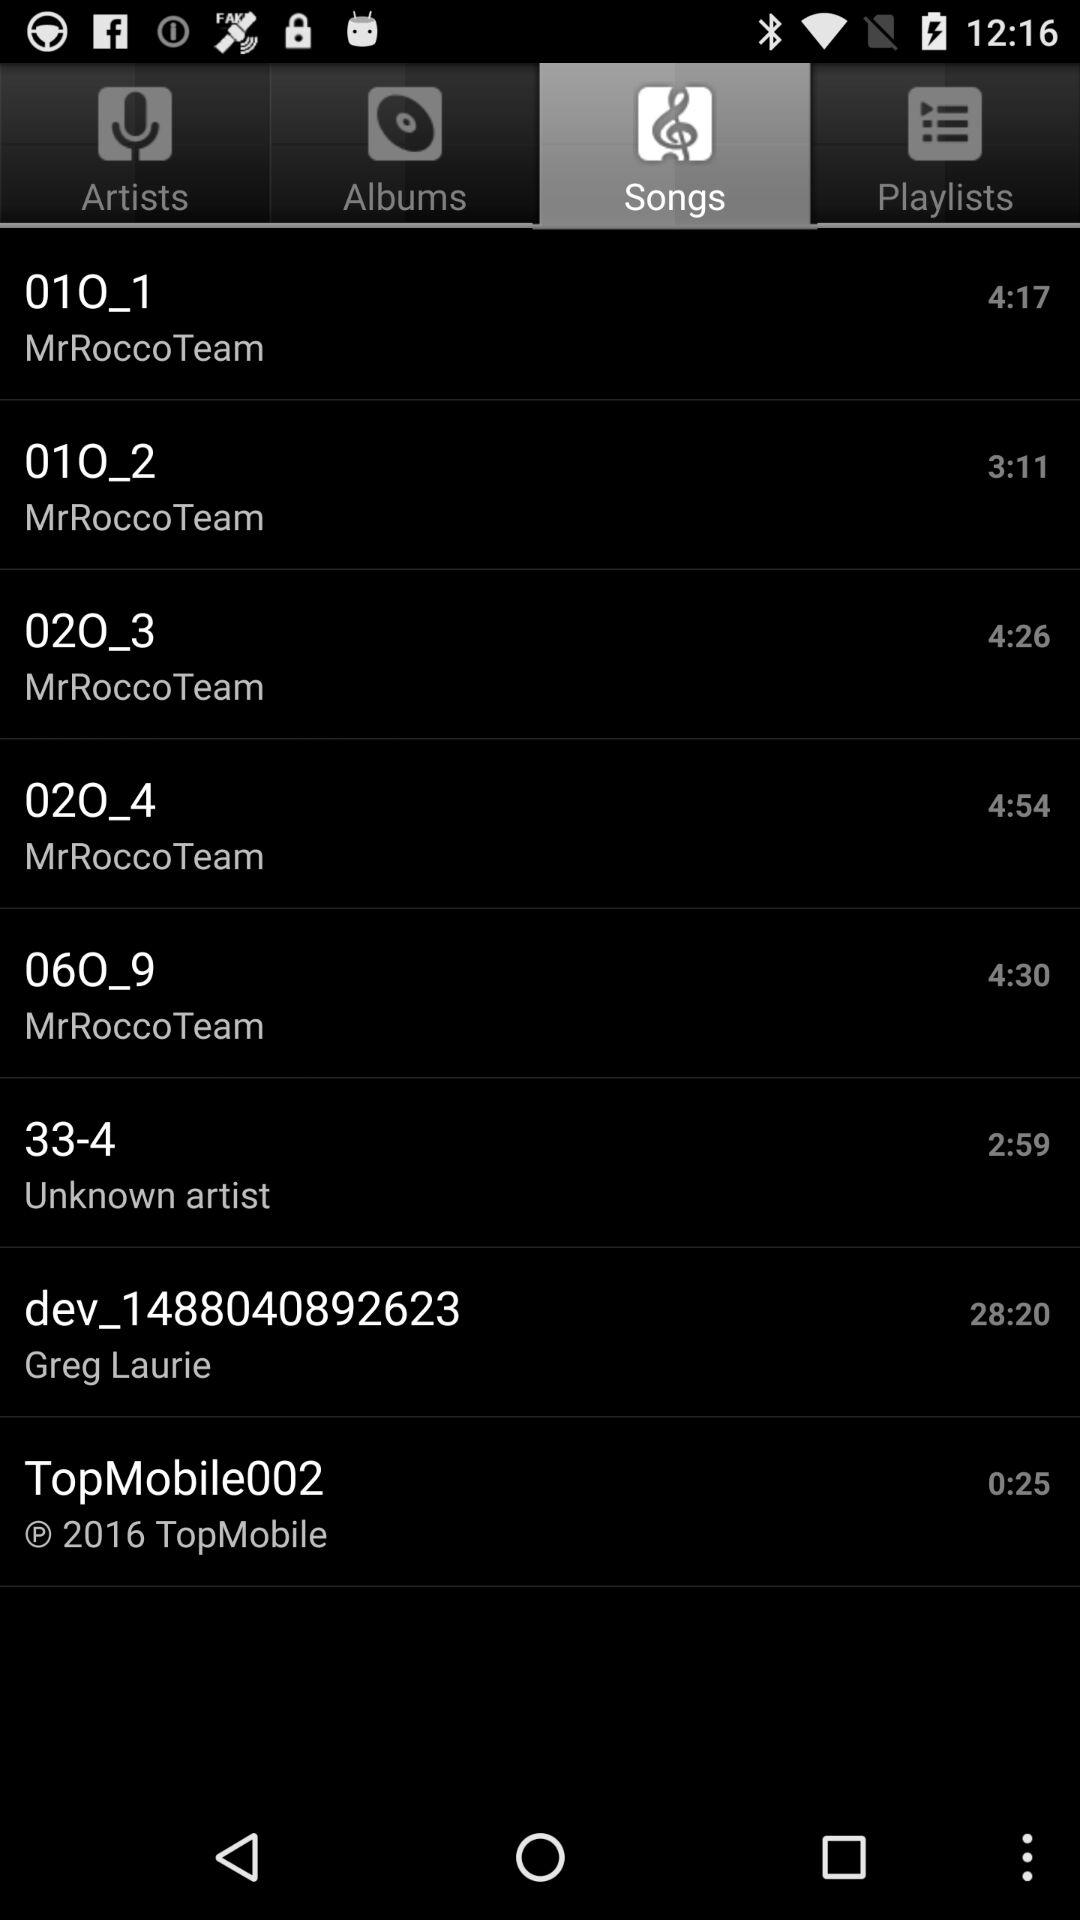What is the time duration of the song "33-4"? The time duration is 2 minutes 59 seconds. 